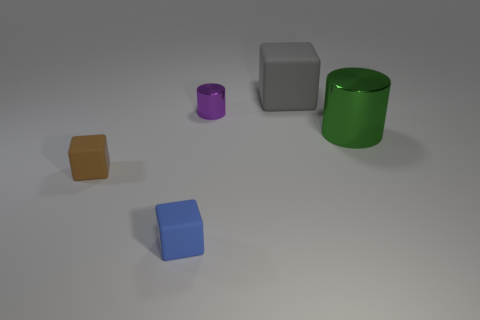What is the size of the blue cube?
Make the answer very short. Small. How big is the metallic object that is on the left side of the metallic cylinder in front of the purple metallic cylinder that is in front of the large gray matte object?
Your answer should be very brief. Small. Are there any tiny balls that have the same material as the small purple thing?
Keep it short and to the point. No. The tiny brown thing has what shape?
Keep it short and to the point. Cube. There is a large cube that is made of the same material as the small brown block; what color is it?
Offer a terse response. Gray. How many brown objects are either tiny metal things or spheres?
Provide a short and direct response. 0. Is the number of brown objects greater than the number of red cylinders?
Provide a short and direct response. Yes. How many objects are either large green shiny cylinders that are on the right side of the gray rubber cube or big things that are to the left of the big metal cylinder?
Ensure brevity in your answer.  2. What is the color of the shiny thing that is the same size as the gray rubber thing?
Your answer should be very brief. Green. Is the big cube made of the same material as the purple thing?
Your answer should be compact. No. 